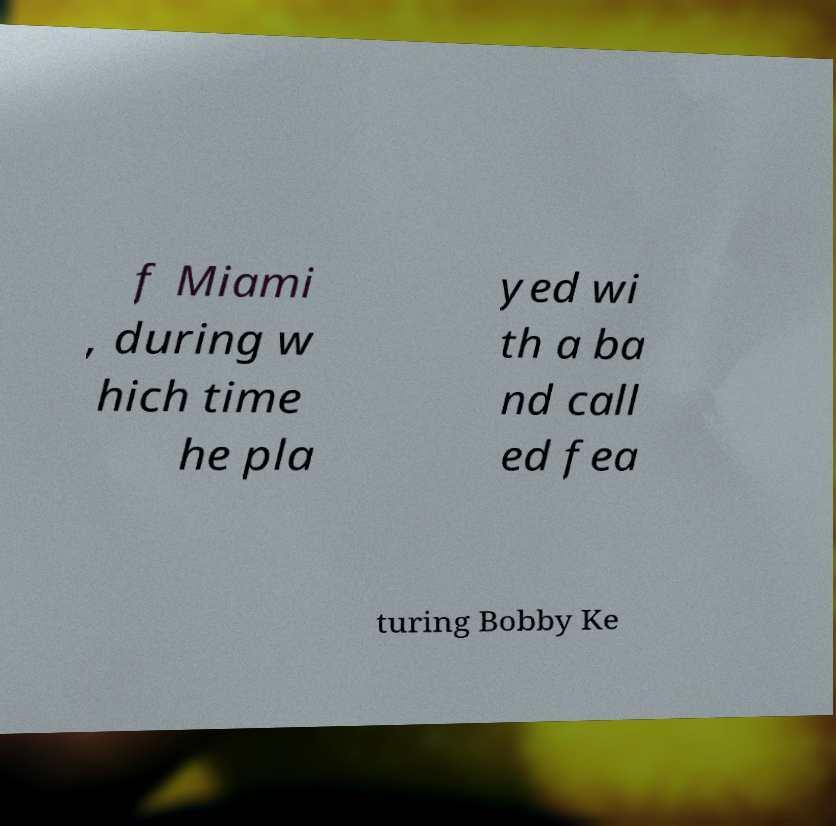What messages or text are displayed in this image? I need them in a readable, typed format. f Miami , during w hich time he pla yed wi th a ba nd call ed fea turing Bobby Ke 